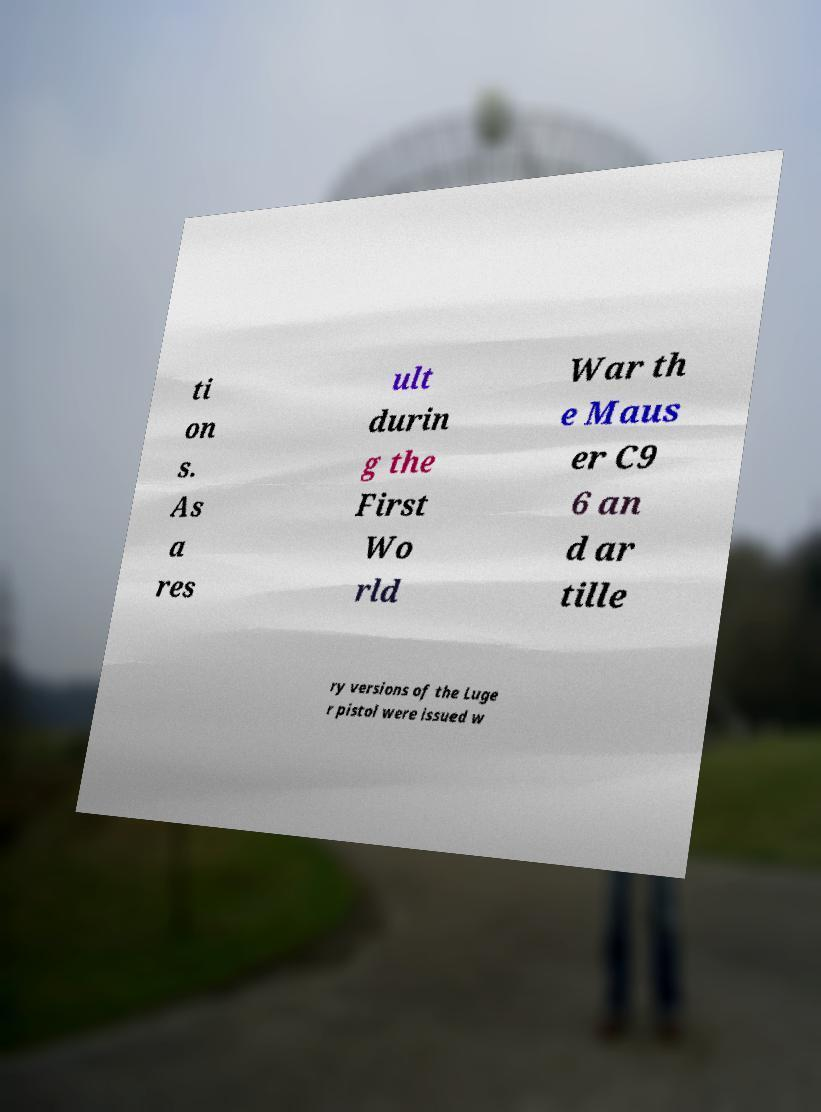Please identify and transcribe the text found in this image. ti on s. As a res ult durin g the First Wo rld War th e Maus er C9 6 an d ar tille ry versions of the Luge r pistol were issued w 